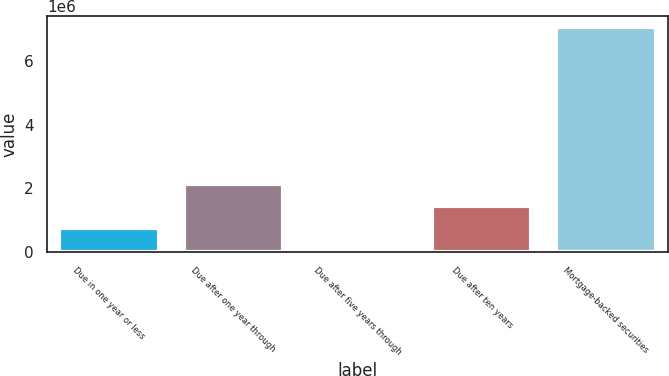<chart> <loc_0><loc_0><loc_500><loc_500><bar_chart><fcel>Due in one year or less<fcel>Due after one year through<fcel>Due after five years through<fcel>Due after ten years<fcel>Mortgage-backed securities<nl><fcel>745297<fcel>2.14845e+06<fcel>43720<fcel>1.44687e+06<fcel>7.05949e+06<nl></chart> 